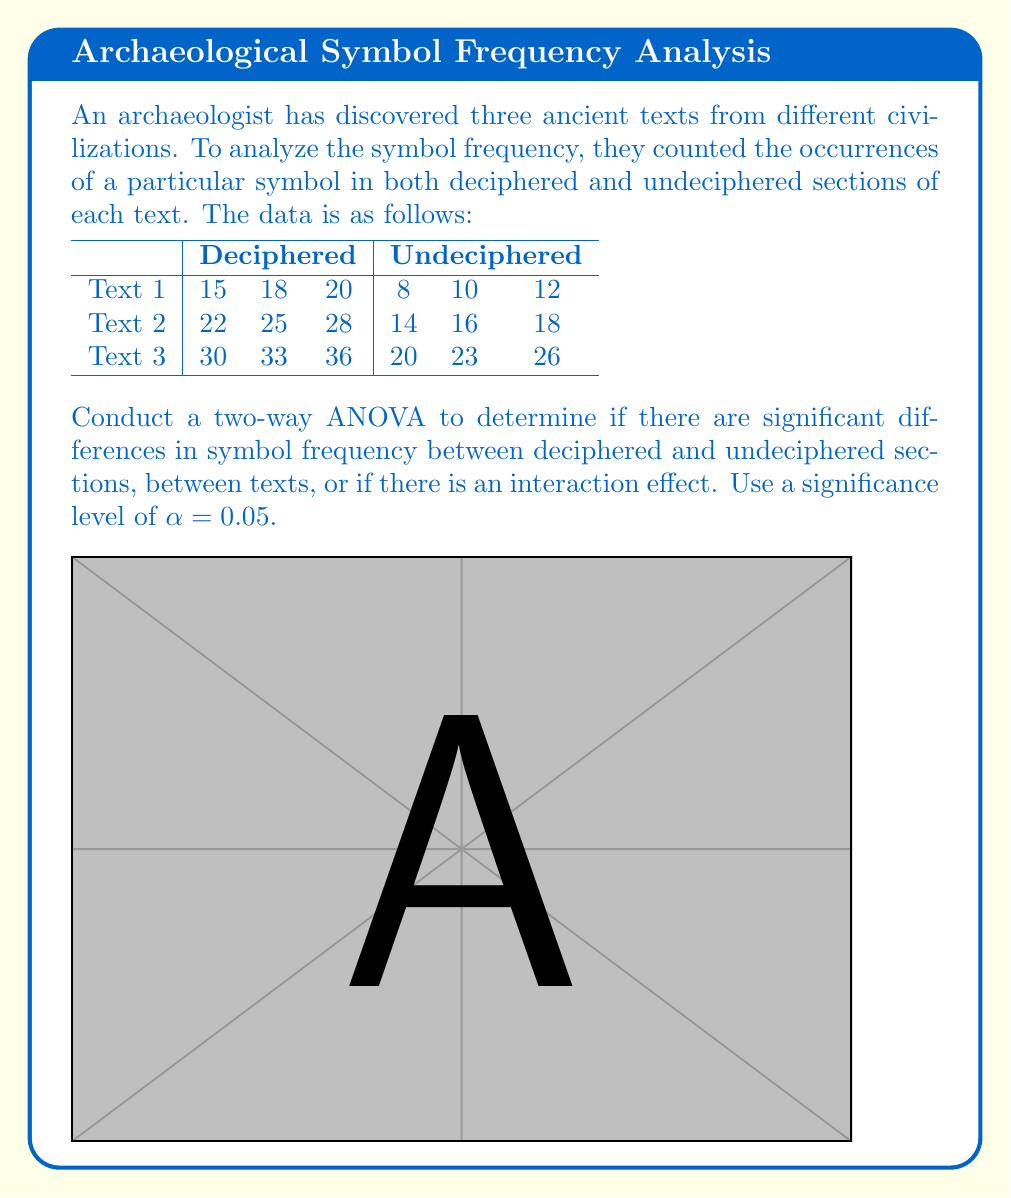Show me your answer to this math problem. To conduct a two-way ANOVA, we'll follow these steps:

1. Calculate the sum of squares for each factor and their interaction:

   a. Total Sum of Squares (SST):
      $SST = \sum (x - \bar{x})^2 = 1494.5$

   b. Sum of Squares for Text (SSA):
      $SSA = n_c \sum (\bar{x}_i - \bar{x})^2 = 882$

   c. Sum of Squares for Deciphered/Undeciphered (SSB):
      $SSB = n_r \sum (\bar{x}_j - \bar{x})^2 = 600$

   d. Sum of Squares for Interaction (SSAB):
      $SSAB = \sum n_{ij} (\bar{x}_{ij} - \bar{x}_i - \bar{x}_j + \bar{x})^2 = 6$

   e. Sum of Squares for Error (SSE):
      $SSE = SST - SSA - SSB - SSAB = 6.5$

2. Calculate the degrees of freedom:
   df(Text) = 2, df(Deciphered/Undeciphered) = 1, df(Interaction) = 2, df(Error) = 12

3. Calculate Mean Squares:
   $MSA = SSA / df_A = 441$
   $MSB = SSB / df_B = 600$
   $MSAB = SSAB / df_{AB} = 3$
   $MSE = SSE / df_E = 0.5417$

4. Calculate F-ratios:
   $F_A = MSA / MSE = 814.13$
   $F_B = MSB / MSE = 1107.69$
   $F_{AB} = MSAB / MSE = 5.54$

5. Compare F-ratios to critical F-values:
   $F_{crit(A)} = F_{0.05,2,12} = 3.89$
   $F_{crit(B)} = F_{0.05,1,12} = 4.75$
   $F_{crit(AB)} = F_{0.05,2,12} = 3.89$

6. Make decisions:
   - Text effect: $F_A > F_{crit(A)}$, so there is a significant effect.
   - Deciphered/Undeciphered effect: $F_B > F_{crit(B)}$, so there is a significant effect.
   - Interaction effect: $F_{AB} > F_{crit(AB)}$, so there is a significant interaction effect.
Answer: Significant differences exist between texts (p < 0.05), between deciphered and undeciphered sections (p < 0.05), and there is a significant interaction effect (p < 0.05). 